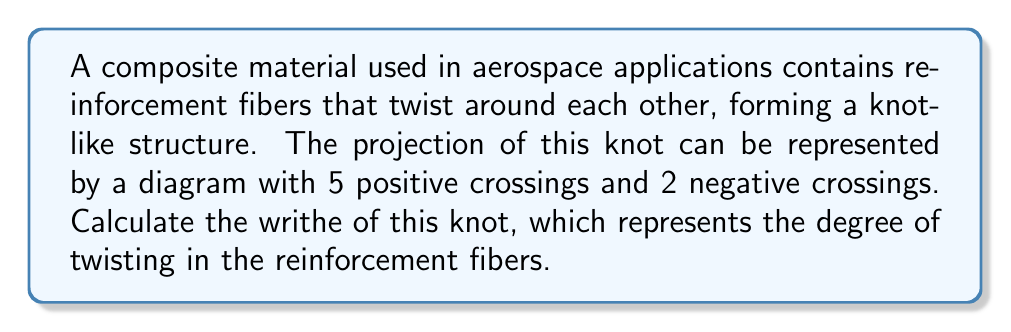Solve this math problem. To calculate the writhe of a knot, we need to follow these steps:

1. Identify the number of positive and negative crossings in the knot diagram:
   - Positive crossings: 5
   - Negative crossings: 2

2. Recall the formula for writhe:
   $$ \text{Writhe} = n_+ - n_- $$
   where $n_+$ is the number of positive crossings and $n_-$ is the number of negative crossings.

3. Substitute the values into the formula:
   $$ \text{Writhe} = 5 - 2 $$

4. Perform the calculation:
   $$ \text{Writhe} = 3 $$

The writhe of 3 indicates that the reinforcement fibers have a net positive twist, which could affect the material's strength and flexibility in aerospace applications.
Answer: 3 